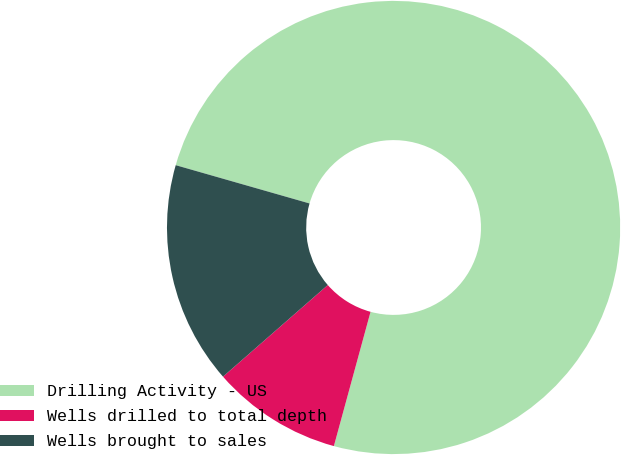<chart> <loc_0><loc_0><loc_500><loc_500><pie_chart><fcel>Drilling Activity - US<fcel>Wells drilled to total depth<fcel>Wells brought to sales<nl><fcel>74.81%<fcel>9.32%<fcel>15.87%<nl></chart> 